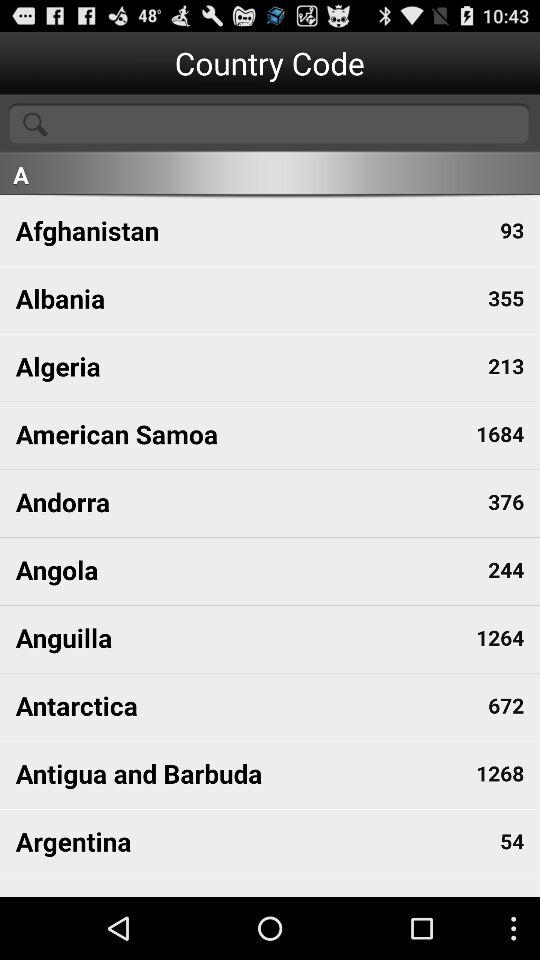What is the country code of Andorra? The country code of Andorra is 376. 